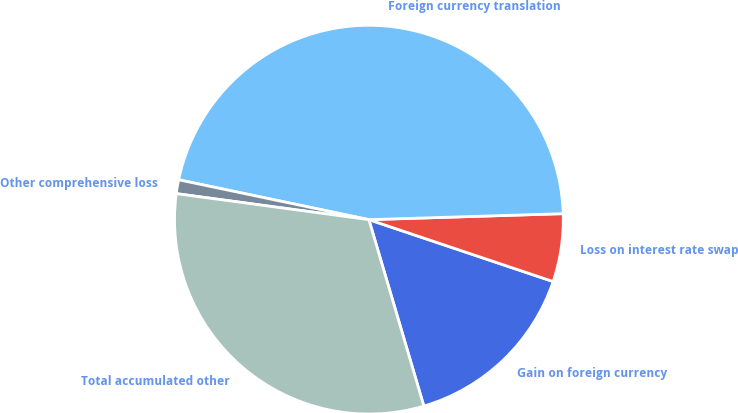<chart> <loc_0><loc_0><loc_500><loc_500><pie_chart><fcel>Gain on foreign currency<fcel>Loss on interest rate swap<fcel>Foreign currency translation<fcel>Other comprehensive loss<fcel>Total accumulated other<nl><fcel>15.28%<fcel>5.65%<fcel>46.22%<fcel>1.15%<fcel>31.7%<nl></chart> 